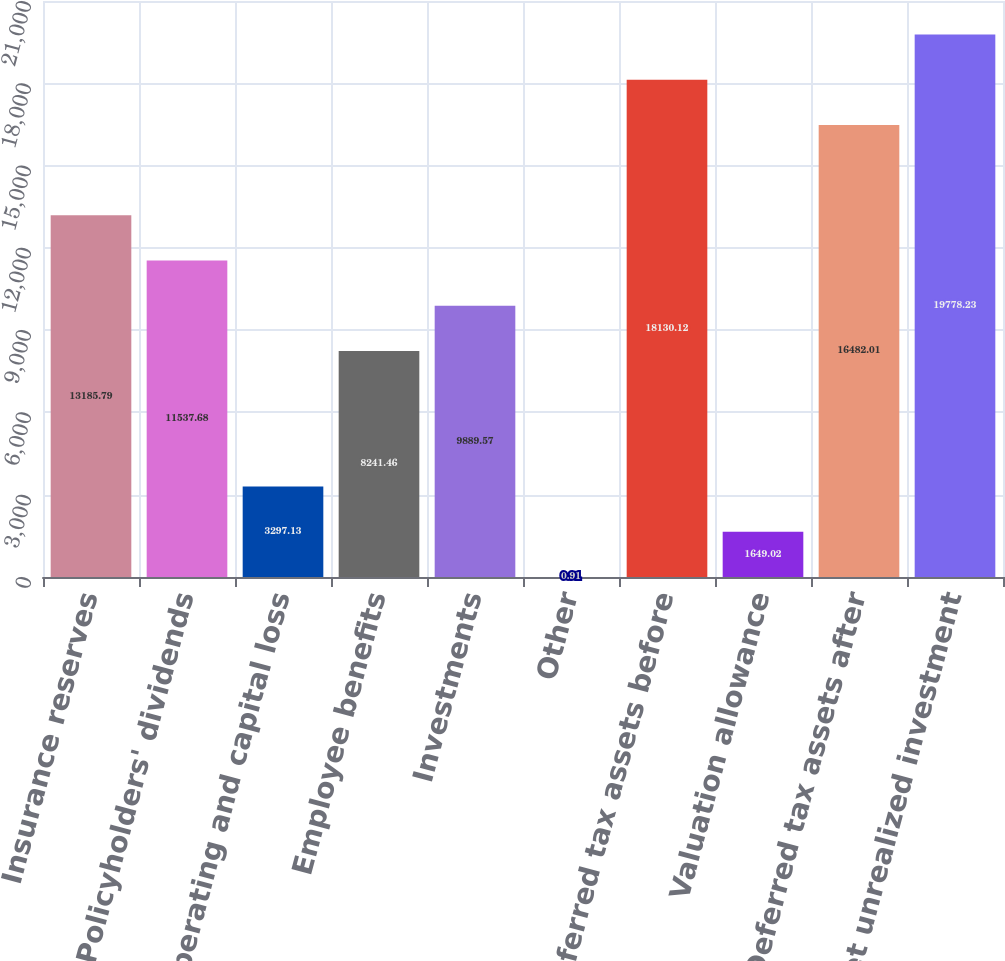Convert chart. <chart><loc_0><loc_0><loc_500><loc_500><bar_chart><fcel>Insurance reserves<fcel>Policyholders' dividends<fcel>Net operating and capital loss<fcel>Employee benefits<fcel>Investments<fcel>Other<fcel>Deferred tax assets before<fcel>Valuation allowance<fcel>Deferred tax assets after<fcel>Net unrealized investment<nl><fcel>13185.8<fcel>11537.7<fcel>3297.13<fcel>8241.46<fcel>9889.57<fcel>0.91<fcel>18130.1<fcel>1649.02<fcel>16482<fcel>19778.2<nl></chart> 